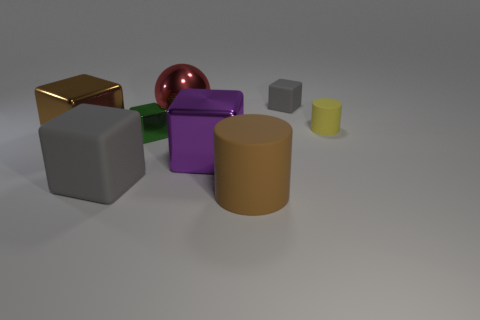Subtract all big brown shiny cubes. How many cubes are left? 4 Subtract all cyan cubes. Subtract all gray cylinders. How many cubes are left? 5 Add 1 big purple metallic things. How many objects exist? 9 Subtract all cylinders. How many objects are left? 6 Add 3 red shiny blocks. How many red shiny blocks exist? 3 Subtract 0 blue cylinders. How many objects are left? 8 Subtract all yellow balls. Subtract all big brown metal things. How many objects are left? 7 Add 8 red metal objects. How many red metal objects are left? 9 